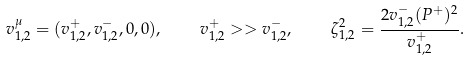<formula> <loc_0><loc_0><loc_500><loc_500>v ^ { \mu } _ { 1 , 2 } = ( v _ { 1 , 2 } ^ { + } , v _ { 1 , 2 } ^ { - } , 0 , 0 ) , \quad v _ { 1 , 2 } ^ { + } > > v _ { 1 , 2 } ^ { - } , \quad \zeta ^ { 2 } _ { 1 , 2 } = \frac { 2 v ^ { - } _ { 1 , 2 } ( P ^ { + } ) ^ { 2 } } { v ^ { + } _ { 1 , 2 } } .</formula> 